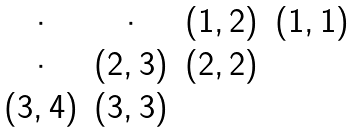<formula> <loc_0><loc_0><loc_500><loc_500>\begin{matrix} \cdot & \cdot & ( 1 , 2 ) & ( 1 , 1 ) \\ \cdot & ( 2 , 3 ) & ( 2 , 2 ) & \\ ( 3 , 4 ) & ( 3 , 3 ) & & \\ \end{matrix}</formula> 